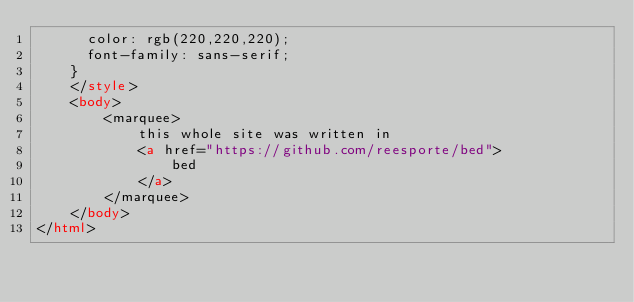Convert code to text. <code><loc_0><loc_0><loc_500><loc_500><_HTML_>			color: rgb(220,220,220);
			font-family: sans-serif;
		}
    </style>
    <body>
        <marquee>
            this whole site was written in
            <a href="https://github.com/reesporte/bed">
                bed
            </a>
        </marquee>
    </body>
</html>
</code> 